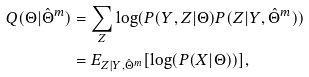<formula> <loc_0><loc_0><loc_500><loc_500>Q ( \Theta | \hat { \Theta } ^ { m } ) & = \sum _ { Z } \log ( P ( Y , Z | \Theta ) P ( Z | Y , \hat { \Theta } ^ { m } ) ) \\ & = E _ { Z | Y , \hat { \Theta } ^ { m } } [ \log ( P ( X | \Theta ) ) ] ,</formula> 